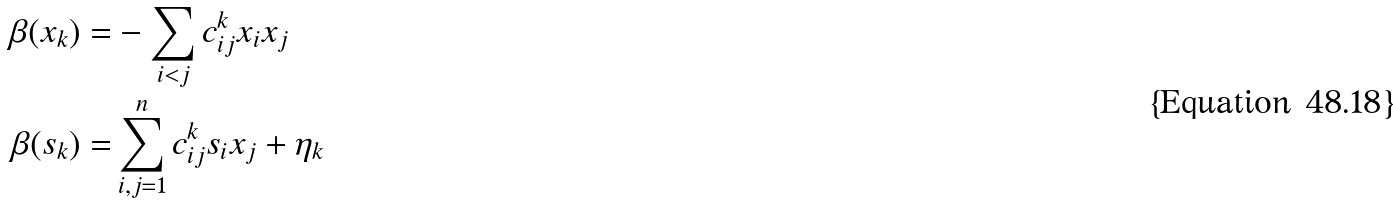<formula> <loc_0><loc_0><loc_500><loc_500>\beta ( x _ { k } ) = & - \sum _ { i < j } c _ { i j } ^ { k } x _ { i } x _ { j } \\ \beta ( s _ { k } ) = & \sum _ { i , j = 1 } ^ { n } c _ { i j } ^ { k } s _ { i } x _ { j } + \eta _ { k }</formula> 